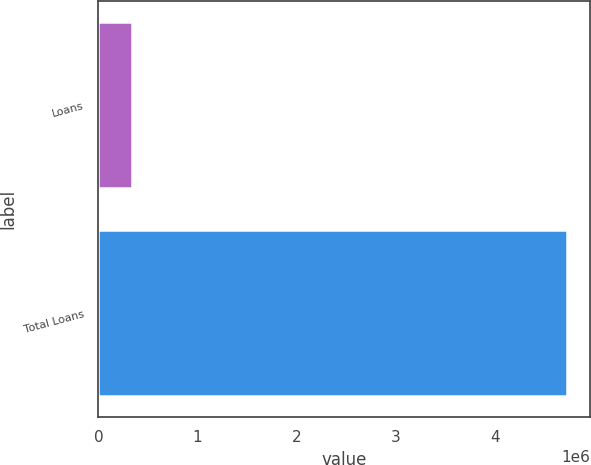<chart> <loc_0><loc_0><loc_500><loc_500><bar_chart><fcel>Loans<fcel>Total Loans<nl><fcel>343783<fcel>4.72447e+06<nl></chart> 